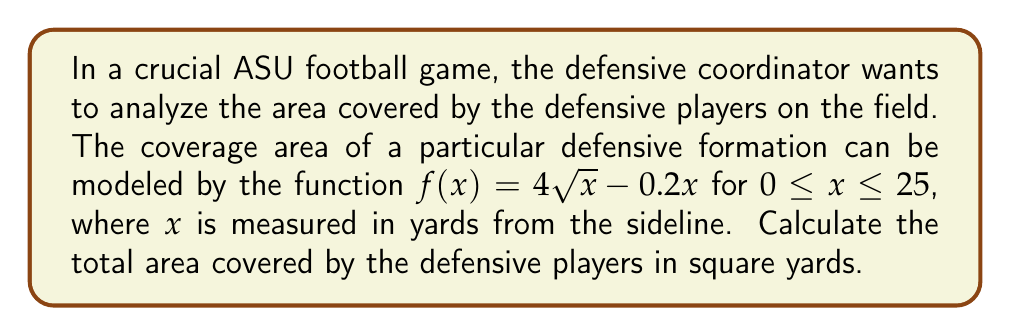Provide a solution to this math problem. To find the area covered by the defensive players, we need to evaluate the definite integral of the given function over the specified interval. Let's break this down step-by-step:

1) The area is given by the definite integral:

   $$A = \int_0^{25} (4\sqrt{x} - 0.2x) dx$$

2) Let's split this into two integrals:

   $$A = \int_0^{25} 4\sqrt{x} dx - \int_0^{25} 0.2x dx$$

3) For the first integral, we can use the power rule with a fractional exponent:
   
   $$\int 4\sqrt{x} dx = 4 \int x^{1/2} dx = 4 \cdot \frac{2}{3}x^{3/2} + C = \frac{8}{3}x^{3/2} + C$$

4) The second integral is straightforward:

   $$\int 0.2x dx = 0.1x^2 + C$$

5) Now, let's apply the limits of integration:

   $$A = \left[\frac{8}{3}x^{3/2} - 0.1x^2\right]_0^{25}$$

6) Evaluating at the upper limit:

   $$\frac{8}{3}(25)^{3/2} - 0.1(25)^2 = \frac{8}{3} \cdot 125 - 62.5 = 333.33 - 62.5 = 270.83$$

7) Evaluating at the lower limit:

   $$\frac{8}{3}(0)^{3/2} - 0.1(0)^2 = 0$$

8) Subtracting the lower limit from the upper limit:

   $$A = 270.83 - 0 = 270.83$$

Therefore, the total area covered by the defensive players is approximately 270.83 square yards.
Answer: $270.83$ square yards 